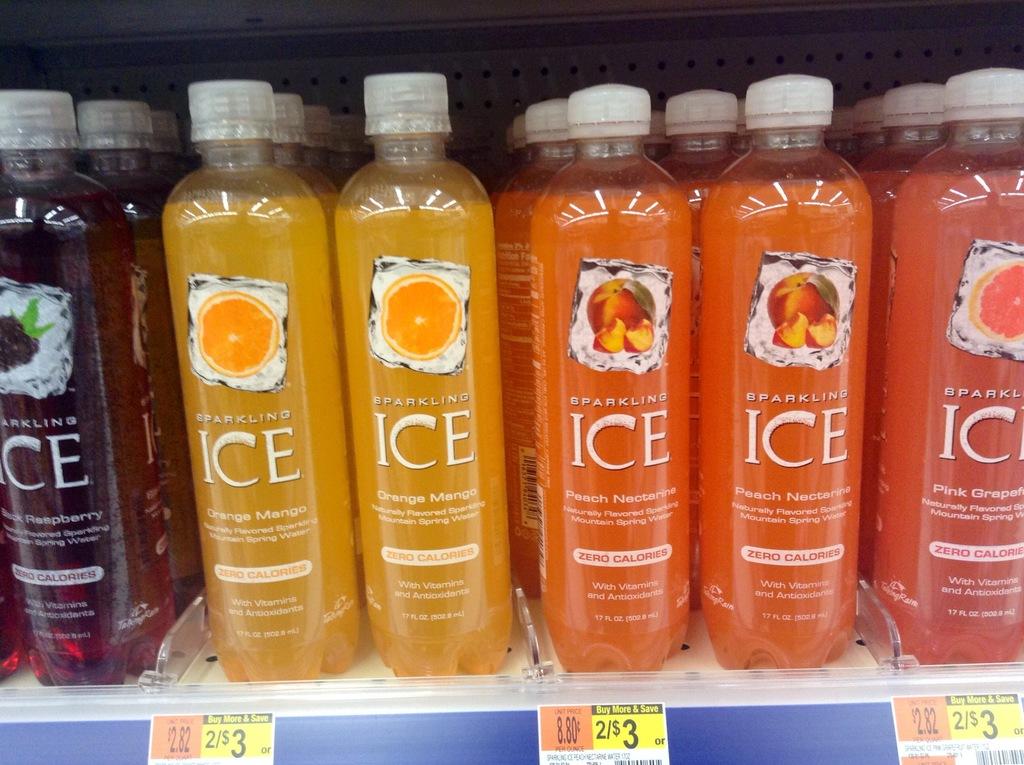What drink is this?
Ensure brevity in your answer.  Sparkling ice. 